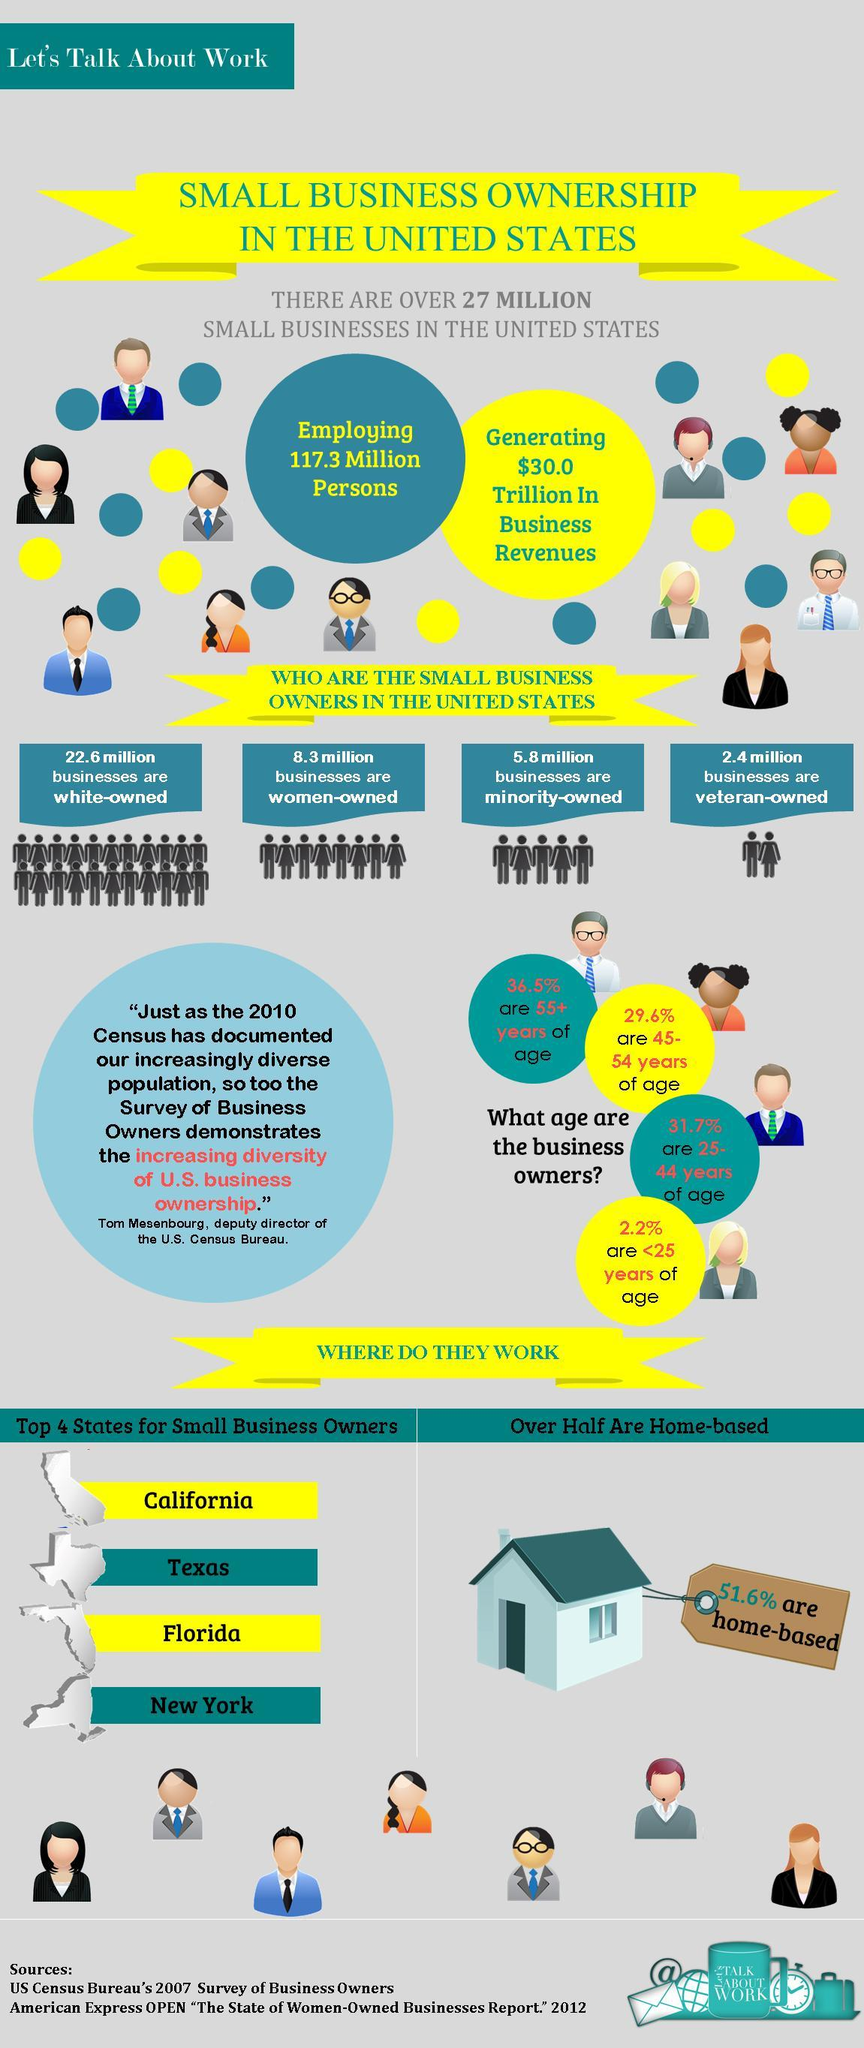What percentage are not home-based business?
Answer the question with a short phrase. 48.4% What percentage are not 25-44 years of age? 68.3% What percentage are not 45-54 years of age? 70.4% What percentage are not 55+ years of age? 63.5% What percentage are not less than 25 years of age? 97.8% 